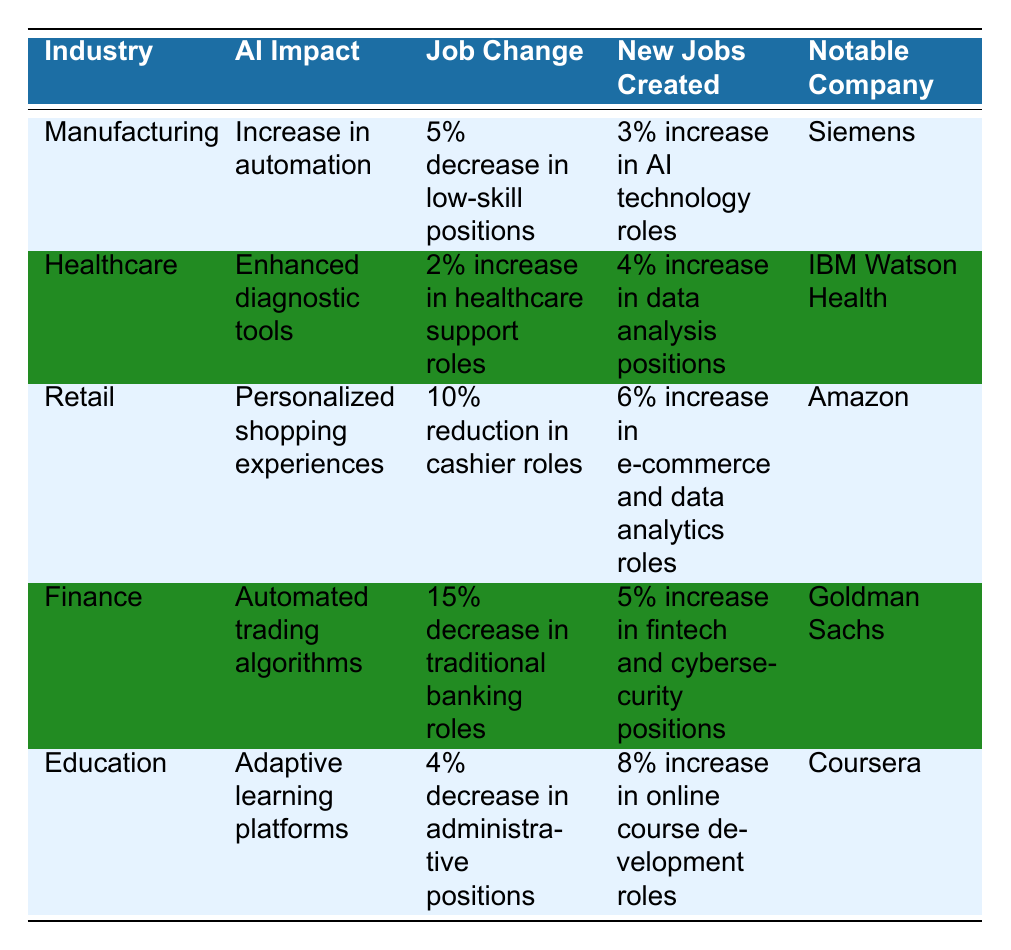What is the impact of AI in the Manufacturing industry? The table indicates that the impact of AI in the Manufacturing industry is an increase in automation.
Answer: Increase in automation Which industry experienced the highest percentage decrease in jobs? By comparing the job changes across industries in the table, Finance shows a 15% decrease in traditional banking roles, which is the highest percentage decrease.
Answer: Finance How many new jobs were created in Healthcare compared to Manufacturing? The new jobs created in Healthcare is a 4% increase in data analysis positions, while Manufacturing created a 3% increase in AI technology roles. Comparing these, Healthcare had 1% more jobs created than Manufacturing.
Answer: Healthcare had 1% more jobs created Is there an increase in healthcare support roles in the Healthcare industry? The table indicates that there is a 2% increase in healthcare support roles in the Healthcare industry. Therefore, the statement is true.
Answer: Yes Which notable company is associated with online course development roles in Education? The table specifies that Coursera is the notable company associated with an 8% increase in online course development roles in Education.
Answer: Coursera What is the overall change in jobs in the Retail industry? In the Retail industry, there is a 10% reduction in cashier roles and a 6% increase in e-commerce and data analytics roles. Therefore, the overall change can be calculated as 6% - 10% = -4%, indicating a net decrease in jobs.
Answer: 4% decrease Which industries had an increase in jobs created, and by how much? The Healthcare industry had a 4% increase and the Manufacturing industry had a 3% increase. The Retail industry had a 6% increase and the Education industry had an 8% increase, resulting in a total of four industries with job increases.
Answer: Four industries had increases Is the statement "Manufacturing had a decrease in low-skill positions" true? The table clearly states that there is a 5% decrease in low-skill positions in the Manufacturing industry. Thus, the statement is true.
Answer: Yes What is the difference in the percentage of new jobs created between Education and Finance? Education shows an 8% increase in online course development roles, while Finance shows a 5% increase in fintech and cybersecurity positions. The difference is 8% - 5% = 3%.
Answer: 3% difference 